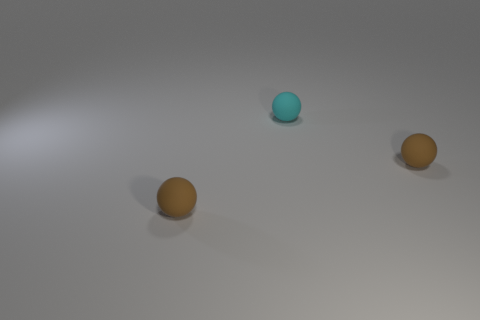What number of spheres are the same material as the cyan object?
Offer a very short reply. 2. There is a small thing that is left of the cyan matte object; does it have the same shape as the tiny rubber object that is right of the cyan rubber thing?
Your response must be concise. Yes. How many other objects are there of the same size as the cyan rubber ball?
Keep it short and to the point. 2. Does the cyan rubber thing have the same size as the brown thing that is right of the cyan matte thing?
Your response must be concise. Yes. What shape is the brown object that is right of the cyan rubber thing?
Ensure brevity in your answer.  Sphere. Are there any other things that are the same material as the tiny cyan thing?
Offer a very short reply. Yes. Are there more small brown rubber things that are in front of the small cyan thing than small cyan spheres?
Your answer should be compact. Yes. How many matte balls are right of the brown rubber object that is to the right of the thing on the left side of the tiny cyan object?
Ensure brevity in your answer.  0. There is a matte sphere to the left of the cyan rubber ball; is its size the same as the brown matte thing that is right of the cyan matte sphere?
Keep it short and to the point. Yes. What is the material of the brown ball on the right side of the brown ball on the left side of the tiny cyan rubber ball?
Your answer should be compact. Rubber. 